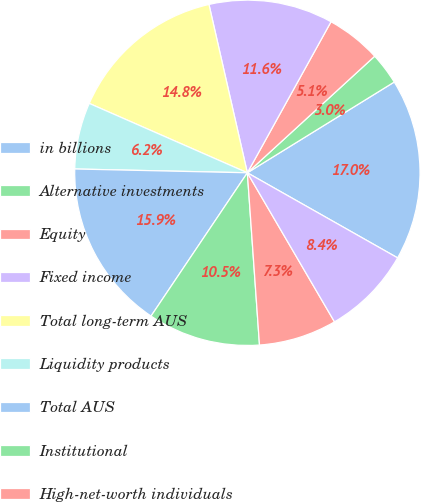<chart> <loc_0><loc_0><loc_500><loc_500><pie_chart><fcel>in billions<fcel>Alternative investments<fcel>Equity<fcel>Fixed income<fcel>Total long-term AUS<fcel>Liquidity products<fcel>Total AUS<fcel>Institutional<fcel>High-net-worth individuals<fcel>Third-party distributed<nl><fcel>17.01%<fcel>2.99%<fcel>5.15%<fcel>11.62%<fcel>14.85%<fcel>6.23%<fcel>15.93%<fcel>10.54%<fcel>7.3%<fcel>8.38%<nl></chart> 